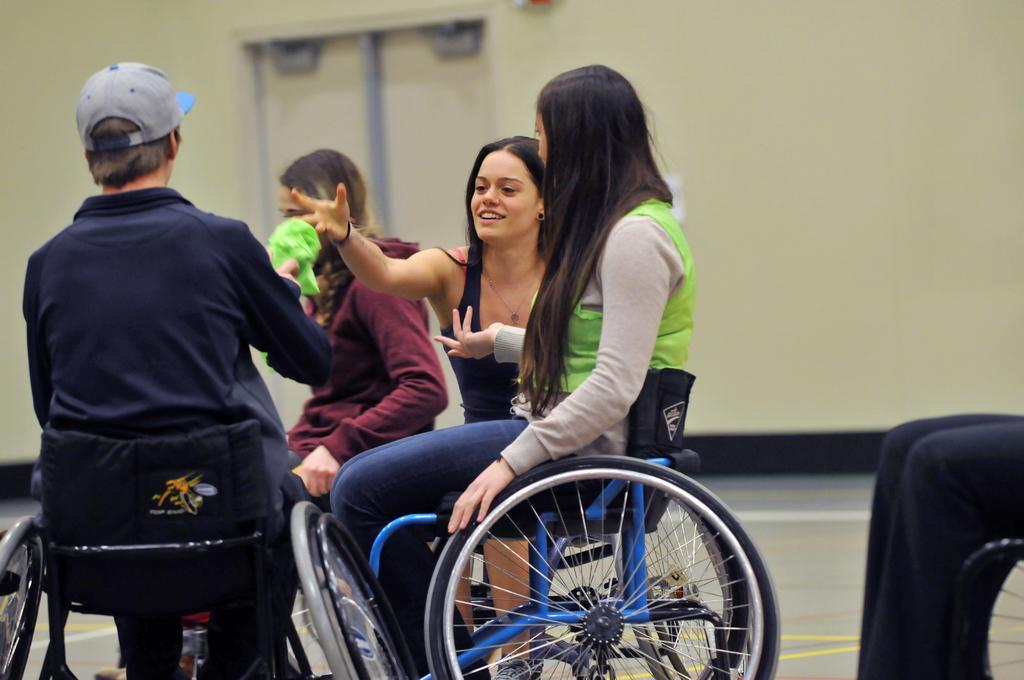Please provide a concise description of this image. In this image I can see four persons sitting on wheelchairs. In the bottom right corner it looks like there is another person on a wheelchair. And In the background there is wall. 